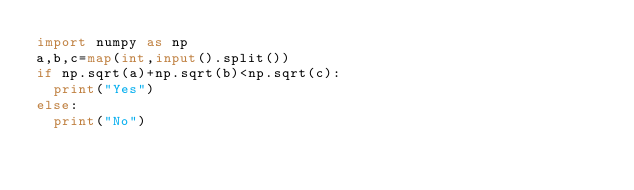<code> <loc_0><loc_0><loc_500><loc_500><_Python_>import numpy as np
a,b,c=map(int,input().split())
if np.sqrt(a)+np.sqrt(b)<np.sqrt(c):
  print("Yes")
else:
  print("No")</code> 